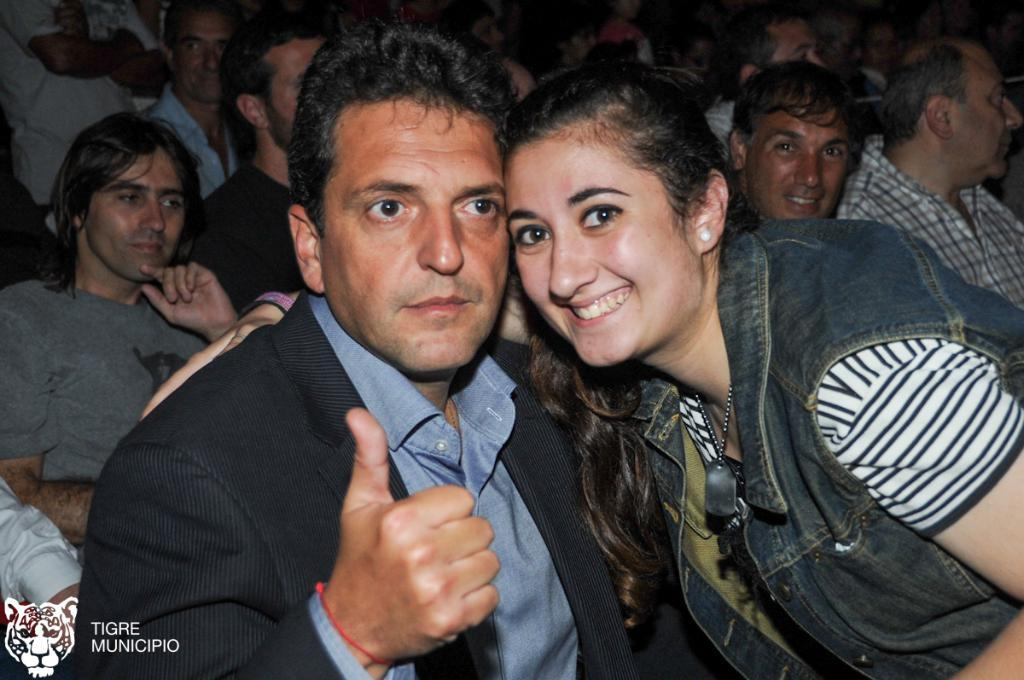How many people are in the image? There are people in the image, but the exact number is not specified. What can be found in the bottom left corner of the image? There is text written in the bottom left corner of the image. What type of card game are the people playing in the image? There is no card game or any indication of an activity being played in the image. 